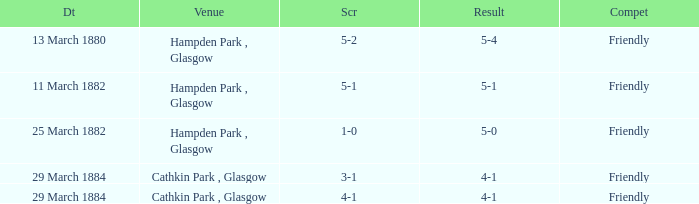Which object led to a score of 4-1? 3-1, 4-1. 